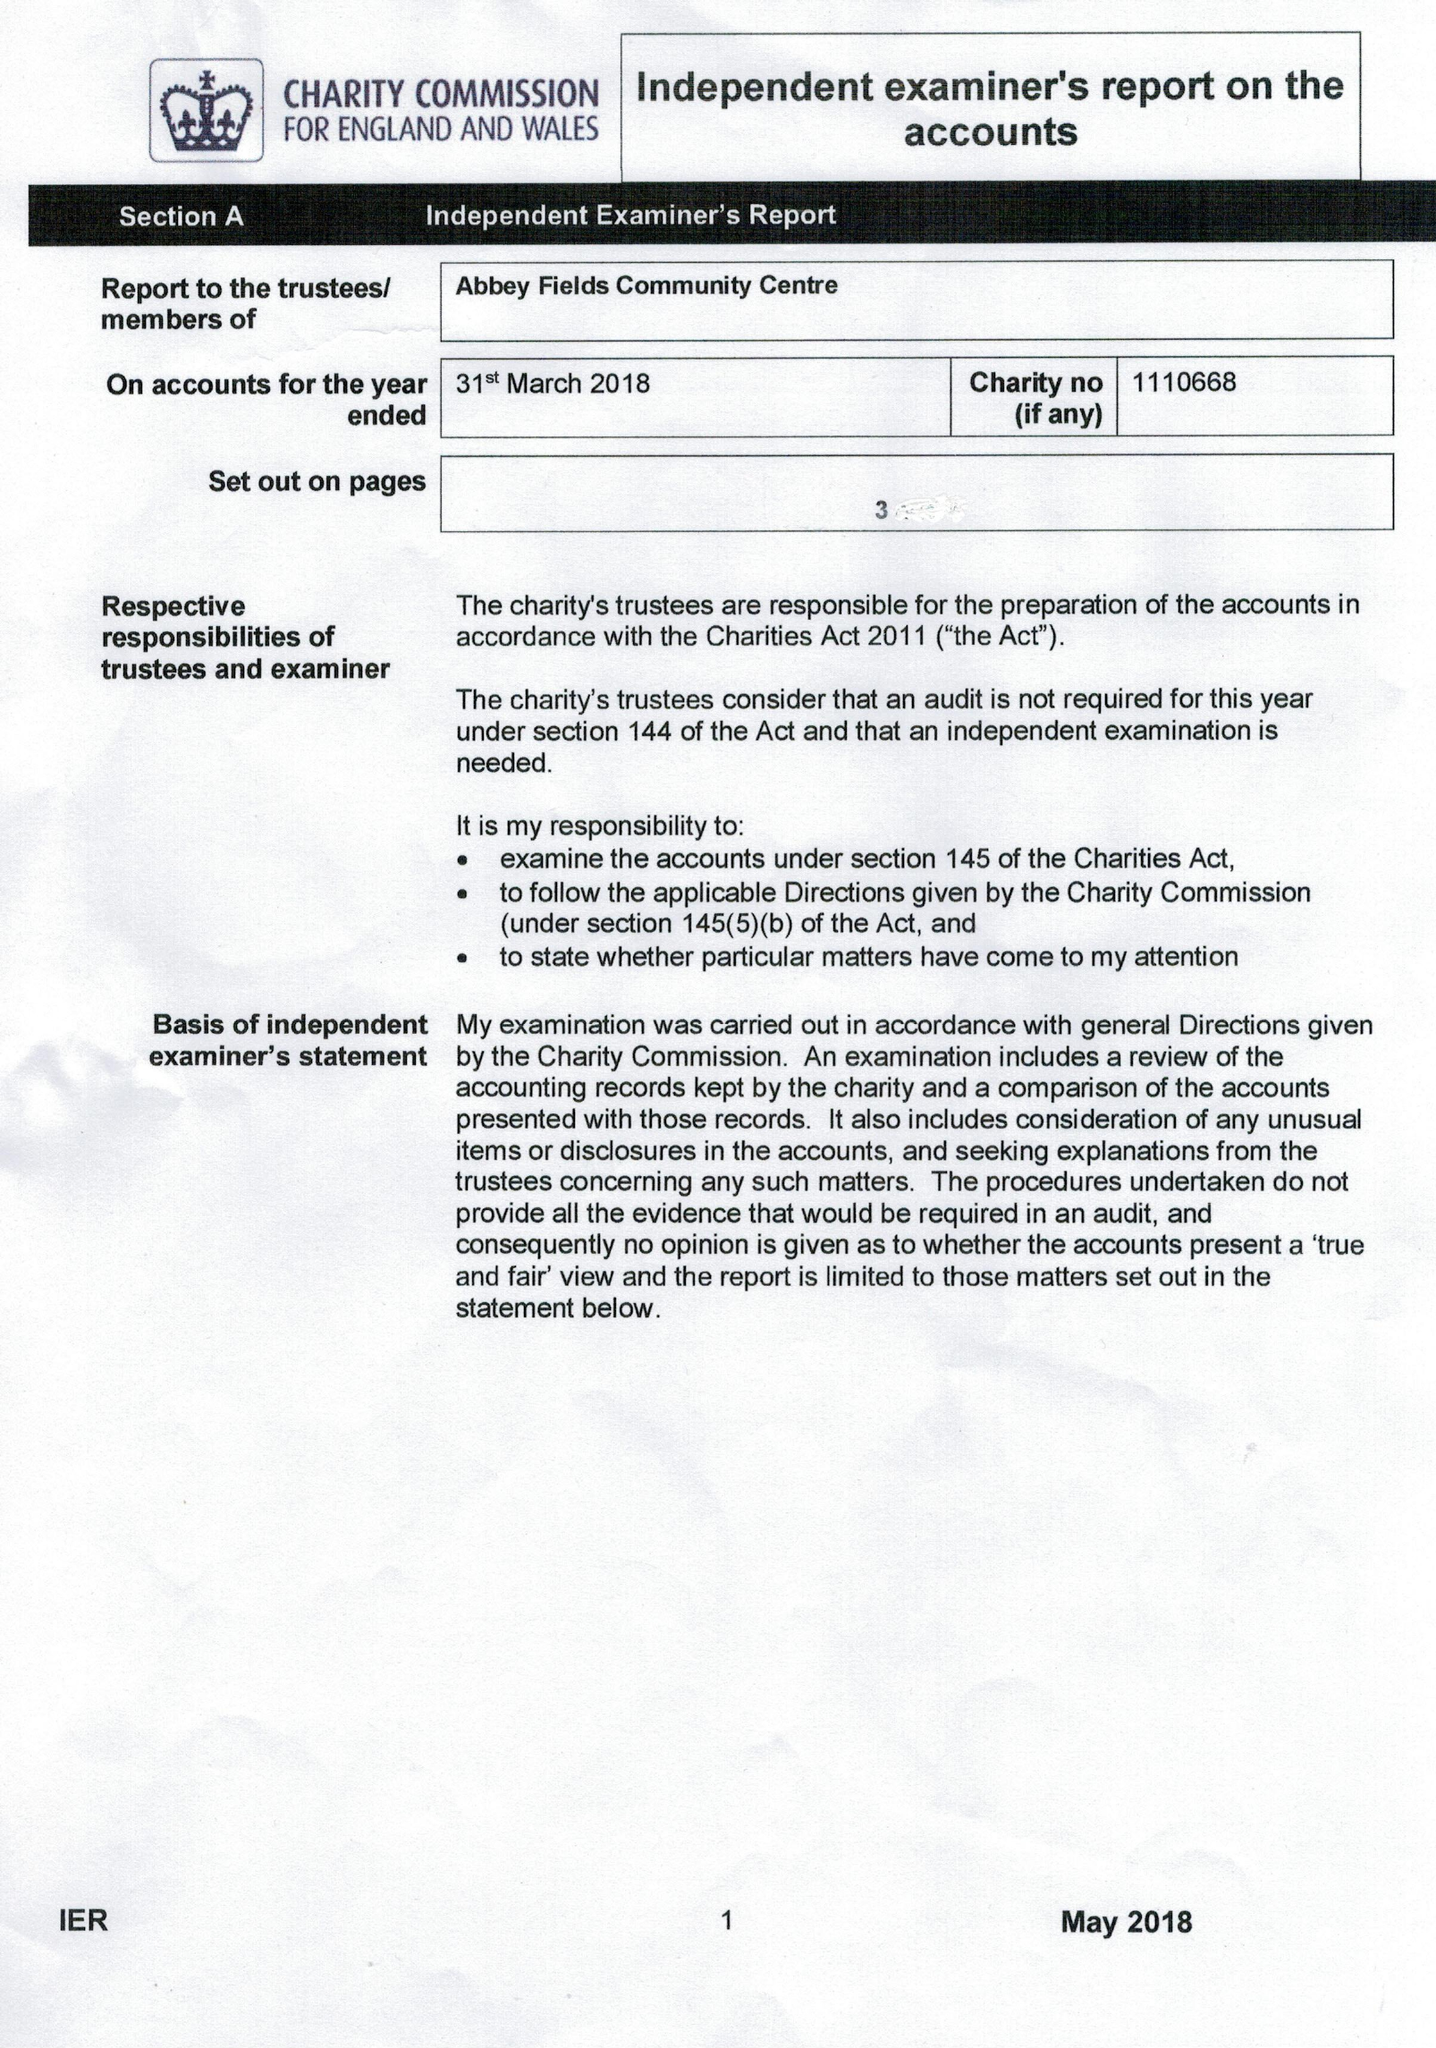What is the value for the charity_number?
Answer the question using a single word or phrase. 1110668 